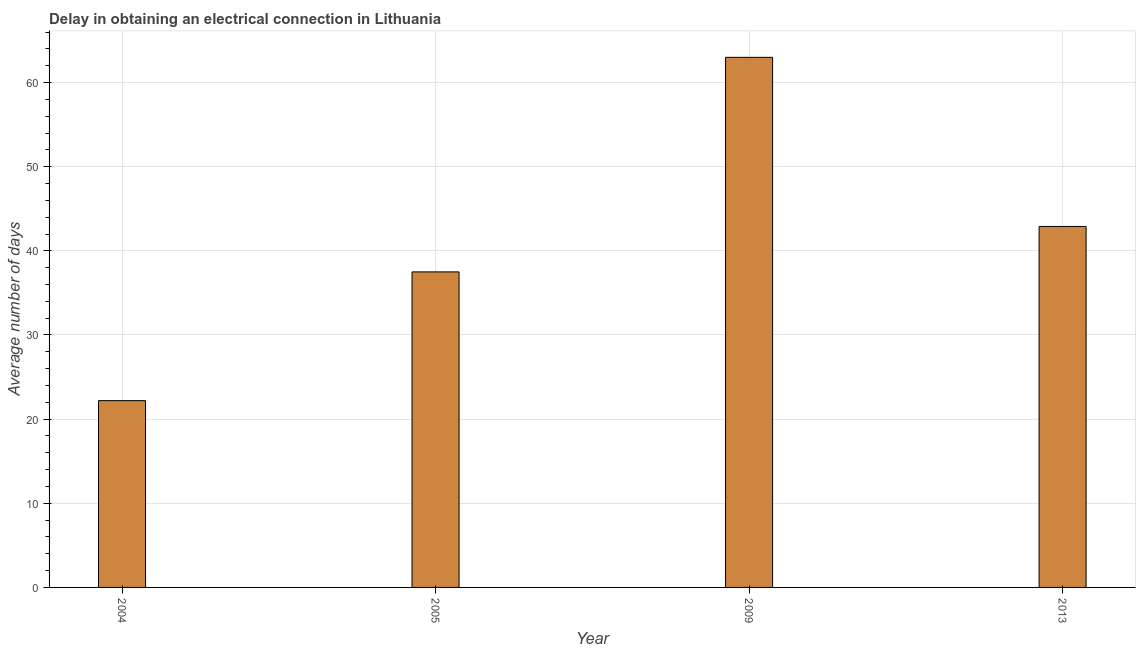Does the graph contain grids?
Offer a terse response. Yes. What is the title of the graph?
Give a very brief answer. Delay in obtaining an electrical connection in Lithuania. What is the label or title of the Y-axis?
Your answer should be very brief. Average number of days. What is the sum of the dalay in electrical connection?
Provide a succinct answer. 165.6. What is the average dalay in electrical connection per year?
Keep it short and to the point. 41.4. What is the median dalay in electrical connection?
Offer a very short reply. 40.2. In how many years, is the dalay in electrical connection greater than 2 days?
Give a very brief answer. 4. Do a majority of the years between 2004 and 2013 (inclusive) have dalay in electrical connection greater than 30 days?
Your answer should be very brief. Yes. What is the ratio of the dalay in electrical connection in 2005 to that in 2009?
Offer a very short reply. 0.59. Is the difference between the dalay in electrical connection in 2004 and 2009 greater than the difference between any two years?
Your answer should be very brief. Yes. What is the difference between the highest and the second highest dalay in electrical connection?
Keep it short and to the point. 20.1. What is the difference between the highest and the lowest dalay in electrical connection?
Offer a very short reply. 40.8. Are all the bars in the graph horizontal?
Provide a short and direct response. No. What is the difference between two consecutive major ticks on the Y-axis?
Your response must be concise. 10. Are the values on the major ticks of Y-axis written in scientific E-notation?
Provide a short and direct response. No. What is the Average number of days of 2004?
Provide a succinct answer. 22.2. What is the Average number of days in 2005?
Ensure brevity in your answer.  37.5. What is the Average number of days of 2013?
Provide a short and direct response. 42.9. What is the difference between the Average number of days in 2004 and 2005?
Make the answer very short. -15.3. What is the difference between the Average number of days in 2004 and 2009?
Provide a short and direct response. -40.8. What is the difference between the Average number of days in 2004 and 2013?
Ensure brevity in your answer.  -20.7. What is the difference between the Average number of days in 2005 and 2009?
Your response must be concise. -25.5. What is the difference between the Average number of days in 2009 and 2013?
Provide a succinct answer. 20.1. What is the ratio of the Average number of days in 2004 to that in 2005?
Give a very brief answer. 0.59. What is the ratio of the Average number of days in 2004 to that in 2009?
Keep it short and to the point. 0.35. What is the ratio of the Average number of days in 2004 to that in 2013?
Offer a very short reply. 0.52. What is the ratio of the Average number of days in 2005 to that in 2009?
Keep it short and to the point. 0.59. What is the ratio of the Average number of days in 2005 to that in 2013?
Ensure brevity in your answer.  0.87. What is the ratio of the Average number of days in 2009 to that in 2013?
Keep it short and to the point. 1.47. 